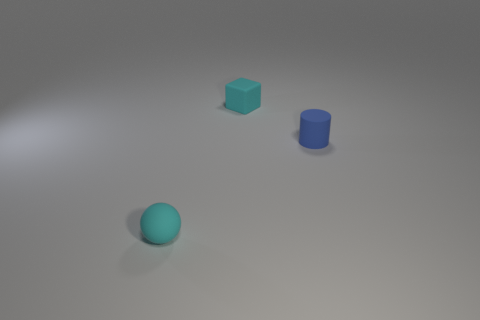Does the tiny blue object have the same material as the small cyan sphere?
Provide a short and direct response. Yes. What number of small cyan spheres are right of the cyan matte ball to the left of the small cyan rubber thing behind the cyan matte ball?
Offer a very short reply. 0. Are there any cyan things made of the same material as the blue cylinder?
Ensure brevity in your answer.  Yes. What size is the thing that is the same color as the small block?
Give a very brief answer. Small. Are there fewer blue cylinders than large red things?
Provide a short and direct response. No. Does the thing that is behind the blue matte object have the same color as the tiny cylinder?
Offer a very short reply. No. The tiny cube behind the blue cylinder on the right side of the cyan rubber object that is behind the cyan rubber sphere is made of what material?
Your answer should be very brief. Rubber. Are there any tiny matte cylinders that have the same color as the small cube?
Provide a succinct answer. No. Are there fewer small cyan matte blocks in front of the cyan matte cube than green things?
Give a very brief answer. No. There is a cyan object that is in front of the blue thing; is its size the same as the small cylinder?
Your response must be concise. Yes. 